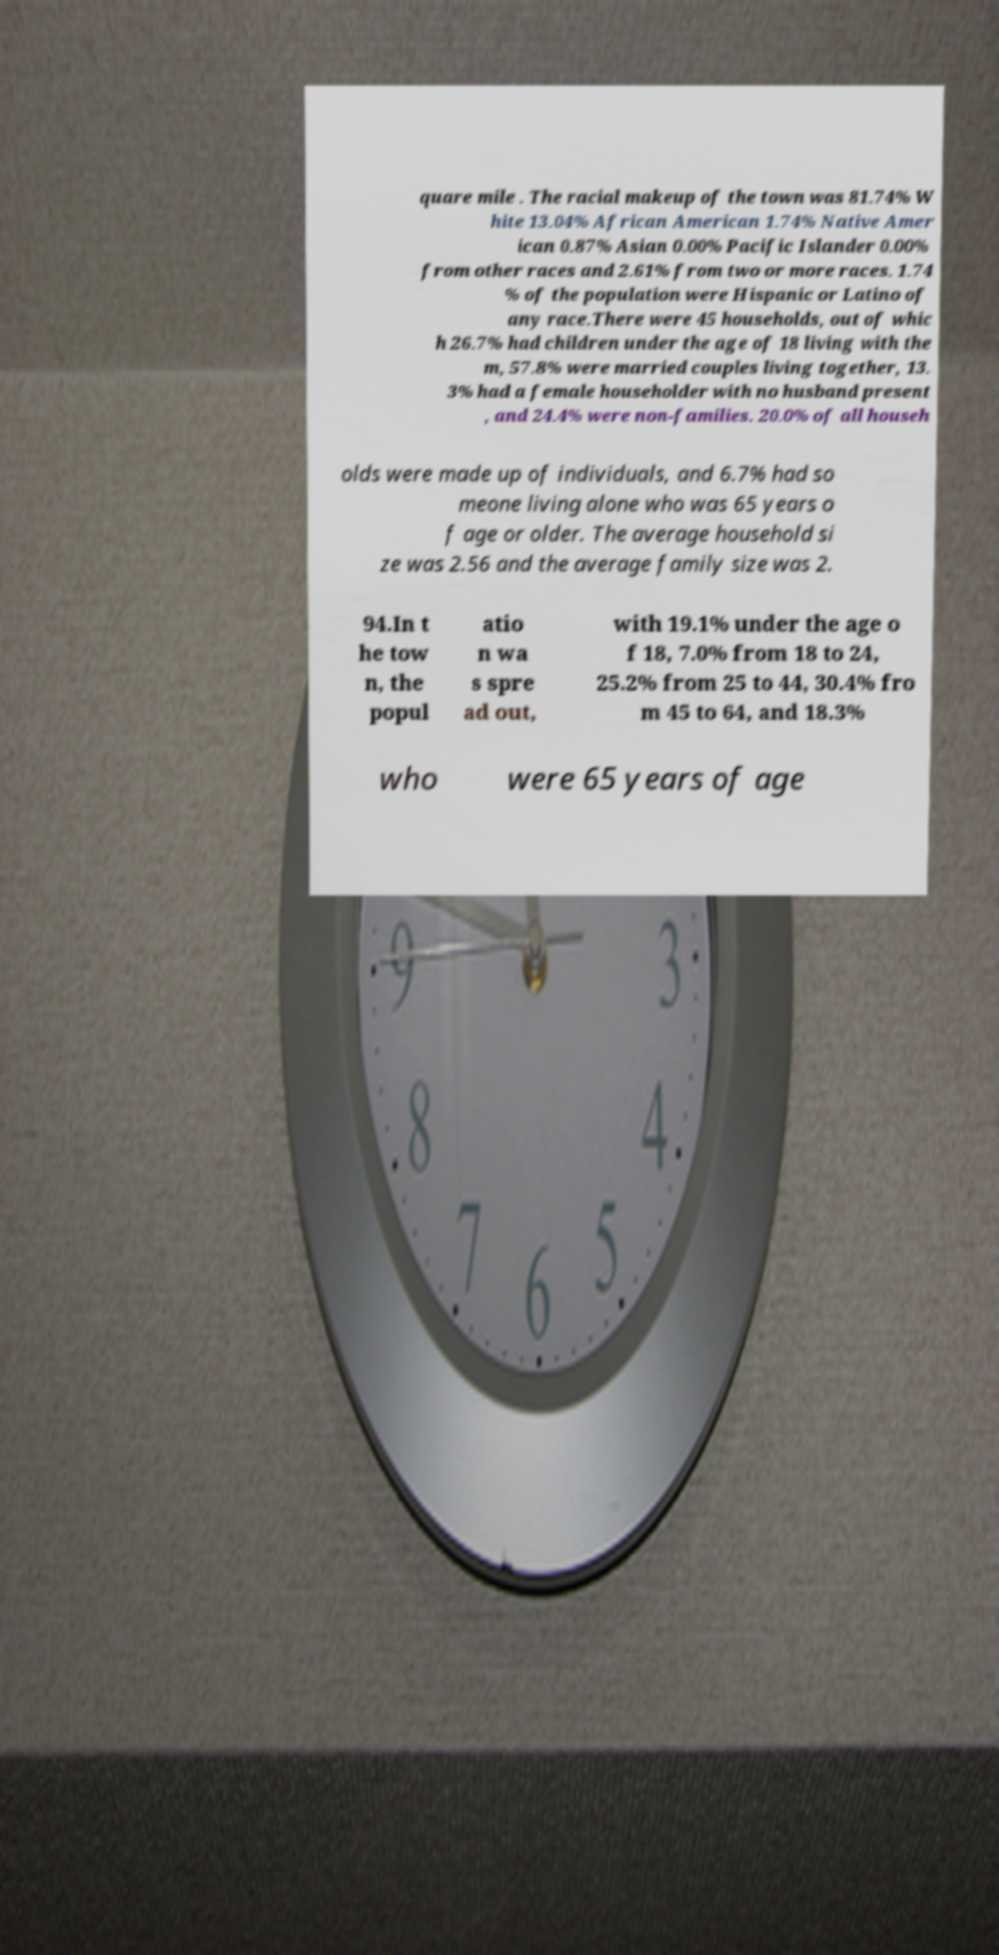Could you extract and type out the text from this image? quare mile . The racial makeup of the town was 81.74% W hite 13.04% African American 1.74% Native Amer ican 0.87% Asian 0.00% Pacific Islander 0.00% from other races and 2.61% from two or more races. 1.74 % of the population were Hispanic or Latino of any race.There were 45 households, out of whic h 26.7% had children under the age of 18 living with the m, 57.8% were married couples living together, 13. 3% had a female householder with no husband present , and 24.4% were non-families. 20.0% of all househ olds were made up of individuals, and 6.7% had so meone living alone who was 65 years o f age or older. The average household si ze was 2.56 and the average family size was 2. 94.In t he tow n, the popul atio n wa s spre ad out, with 19.1% under the age o f 18, 7.0% from 18 to 24, 25.2% from 25 to 44, 30.4% fro m 45 to 64, and 18.3% who were 65 years of age 